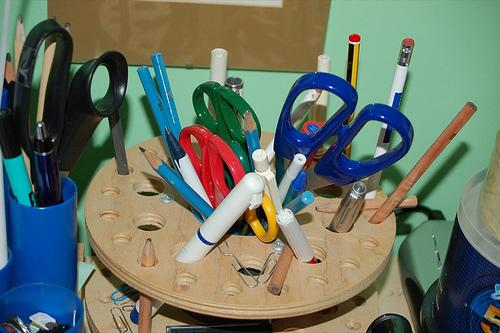What class are these supplies needed for?

Choices:
A) english class
B) gym class
C) math class
D) art class art class 